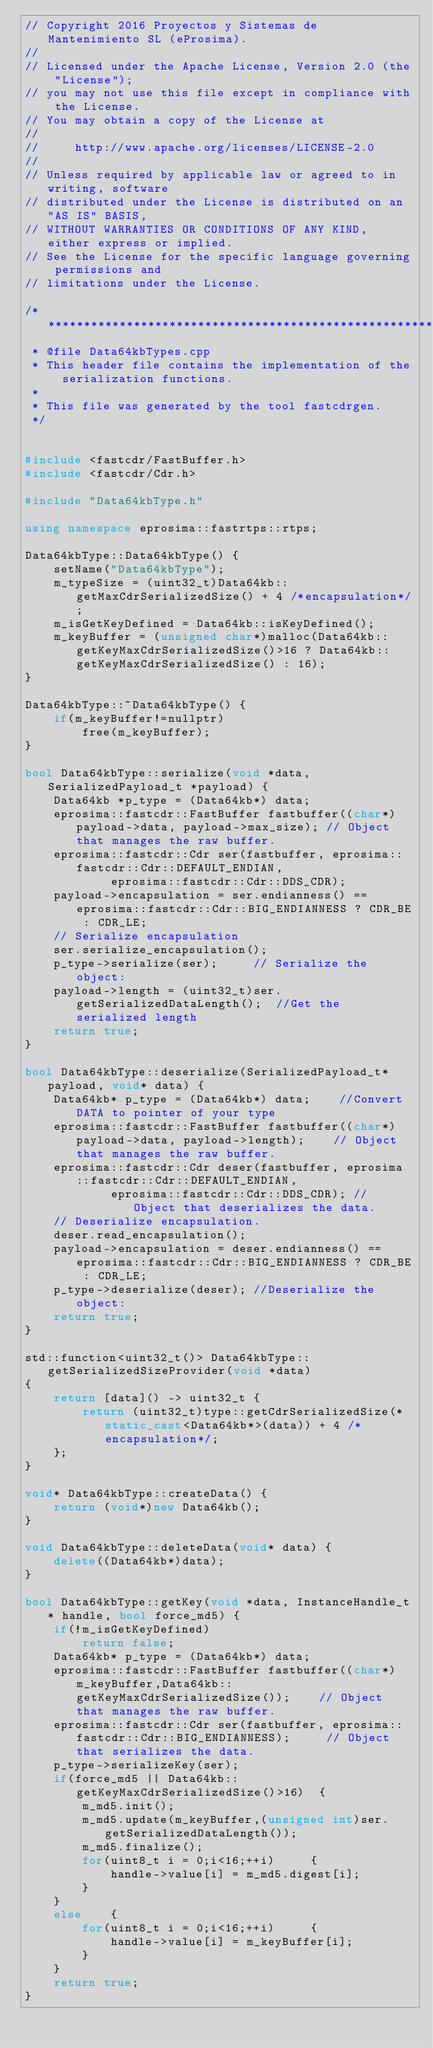<code> <loc_0><loc_0><loc_500><loc_500><_C++_>// Copyright 2016 Proyectos y Sistemas de Mantenimiento SL (eProsima).
//
// Licensed under the Apache License, Version 2.0 (the "License");
// you may not use this file except in compliance with the License.
// You may obtain a copy of the License at
//
//     http://www.apache.org/licenses/LICENSE-2.0
//
// Unless required by applicable law or agreed to in writing, software
// distributed under the License is distributed on an "AS IS" BASIS,
// WITHOUT WARRANTIES OR CONDITIONS OF ANY KIND, either express or implied.
// See the License for the specific language governing permissions and
// limitations under the License.

/*************************************************************************
 * @file Data64kbTypes.cpp
 * This header file contains the implementation of the serialization functions.
 *
 * This file was generated by the tool fastcdrgen.
 */


#include <fastcdr/FastBuffer.h>
#include <fastcdr/Cdr.h>

#include "Data64kbType.h"

using namespace eprosima::fastrtps::rtps;

Data64kbType::Data64kbType() {
    setName("Data64kbType");
    m_typeSize = (uint32_t)Data64kb::getMaxCdrSerializedSize() + 4 /*encapsulation*/;
    m_isGetKeyDefined = Data64kb::isKeyDefined();
    m_keyBuffer = (unsigned char*)malloc(Data64kb::getKeyMaxCdrSerializedSize()>16 ? Data64kb::getKeyMaxCdrSerializedSize() : 16);
}

Data64kbType::~Data64kbType() {
    if(m_keyBuffer!=nullptr)
        free(m_keyBuffer);
}

bool Data64kbType::serialize(void *data, SerializedPayload_t *payload) {
    Data64kb *p_type = (Data64kb*) data;
    eprosima::fastcdr::FastBuffer fastbuffer((char*)payload->data, payload->max_size); // Object that manages the raw buffer.
    eprosima::fastcdr::Cdr ser(fastbuffer, eprosima::fastcdr::Cdr::DEFAULT_ENDIAN,
            eprosima::fastcdr::Cdr::DDS_CDR);
    payload->encapsulation = ser.endianness() == eprosima::fastcdr::Cdr::BIG_ENDIANNESS ? CDR_BE : CDR_LE;
    // Serialize encapsulation
    ser.serialize_encapsulation();
    p_type->serialize(ser); 	// Serialize the object:
    payload->length = (uint32_t)ser.getSerializedDataLength(); 	//Get the serialized length
    return true;
}

bool Data64kbType::deserialize(SerializedPayload_t* payload, void* data) {
    Data64kb* p_type = (Data64kb*) data; 	//Convert DATA to pointer of your type
    eprosima::fastcdr::FastBuffer fastbuffer((char*)payload->data, payload->length); 	// Object that manages the raw buffer.
    eprosima::fastcdr::Cdr deser(fastbuffer, eprosima::fastcdr::Cdr::DEFAULT_ENDIAN,
            eprosima::fastcdr::Cdr::DDS_CDR); // Object that deserializes the data.
    // Deserialize encapsulation.
    deser.read_encapsulation();
    payload->encapsulation = deser.endianness() == eprosima::fastcdr::Cdr::BIG_ENDIANNESS ? CDR_BE : CDR_LE;
    p_type->deserialize(deser);	//Deserialize the object:
    return true;
}

std::function<uint32_t()> Data64kbType::getSerializedSizeProvider(void *data)
{
    return [data]() -> uint32_t {
        return (uint32_t)type::getCdrSerializedSize(*static_cast<Data64kb*>(data)) + 4 /*encapsulation*/;
    };
}

void* Data64kbType::createData() {
    return (void*)new Data64kb();
}

void Data64kbType::deleteData(void* data) {
    delete((Data64kb*)data);
}

bool Data64kbType::getKey(void *data, InstanceHandle_t* handle, bool force_md5) {
    if(!m_isGetKeyDefined)
        return false;
    Data64kb* p_type = (Data64kb*) data;
    eprosima::fastcdr::FastBuffer fastbuffer((char*)m_keyBuffer,Data64kb::getKeyMaxCdrSerializedSize()); 	// Object that manages the raw buffer.
    eprosima::fastcdr::Cdr ser(fastbuffer, eprosima::fastcdr::Cdr::BIG_ENDIANNESS); 	// Object that serializes the data.
    p_type->serializeKey(ser);
    if(force_md5 || Data64kb::getKeyMaxCdrSerializedSize()>16)	{
        m_md5.init();
        m_md5.update(m_keyBuffer,(unsigned int)ser.getSerializedDataLength());
        m_md5.finalize();
        for(uint8_t i = 0;i<16;++i)    	{
            handle->value[i] = m_md5.digest[i];
        }
    }
    else    {
        for(uint8_t i = 0;i<16;++i)    	{
            handle->value[i] = m_keyBuffer[i];
        }
    }
    return true;
}

</code> 